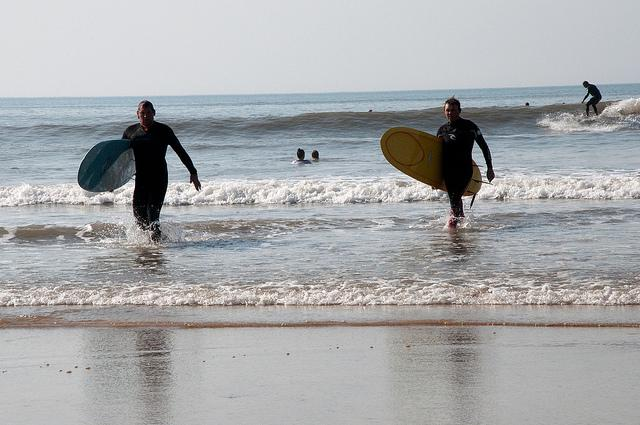What color is the surfboard held by the man walking up the beach on the right? yellow 